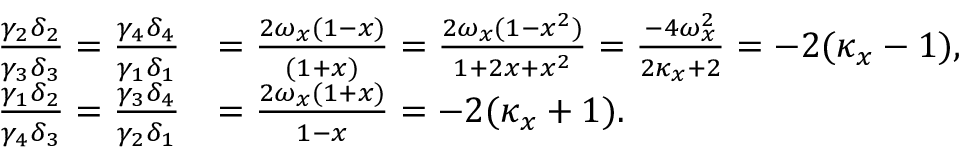Convert formula to latex. <formula><loc_0><loc_0><loc_500><loc_500>\begin{array} { r l } { \frac { \gamma _ { 2 } \delta _ { 2 } } { \gamma _ { 3 } \delta _ { 3 } } = \frac { \gamma _ { 4 } \delta _ { 4 } } { \gamma _ { 1 } \delta _ { 1 } } } & { = \frac { 2 \omega _ { x } ( 1 - x ) } { ( 1 + x ) } = \frac { 2 \omega _ { x } ( 1 - x ^ { 2 } ) } { 1 + 2 x + x ^ { 2 } } = \frac { - 4 \omega _ { x } ^ { 2 } } { 2 \kappa _ { x } + 2 } = - 2 ( \kappa _ { x } - 1 ) , } \\ { \frac { \gamma _ { 1 } \delta _ { 2 } } { \gamma _ { 4 } \delta _ { 3 } } = \frac { \gamma _ { 3 } \delta _ { 4 } } { \gamma _ { 2 } \delta _ { 1 } } } & { = \frac { 2 \omega _ { x } ( 1 + x ) } { 1 - x } = - 2 ( \kappa _ { x } + 1 ) . } \end{array}</formula> 